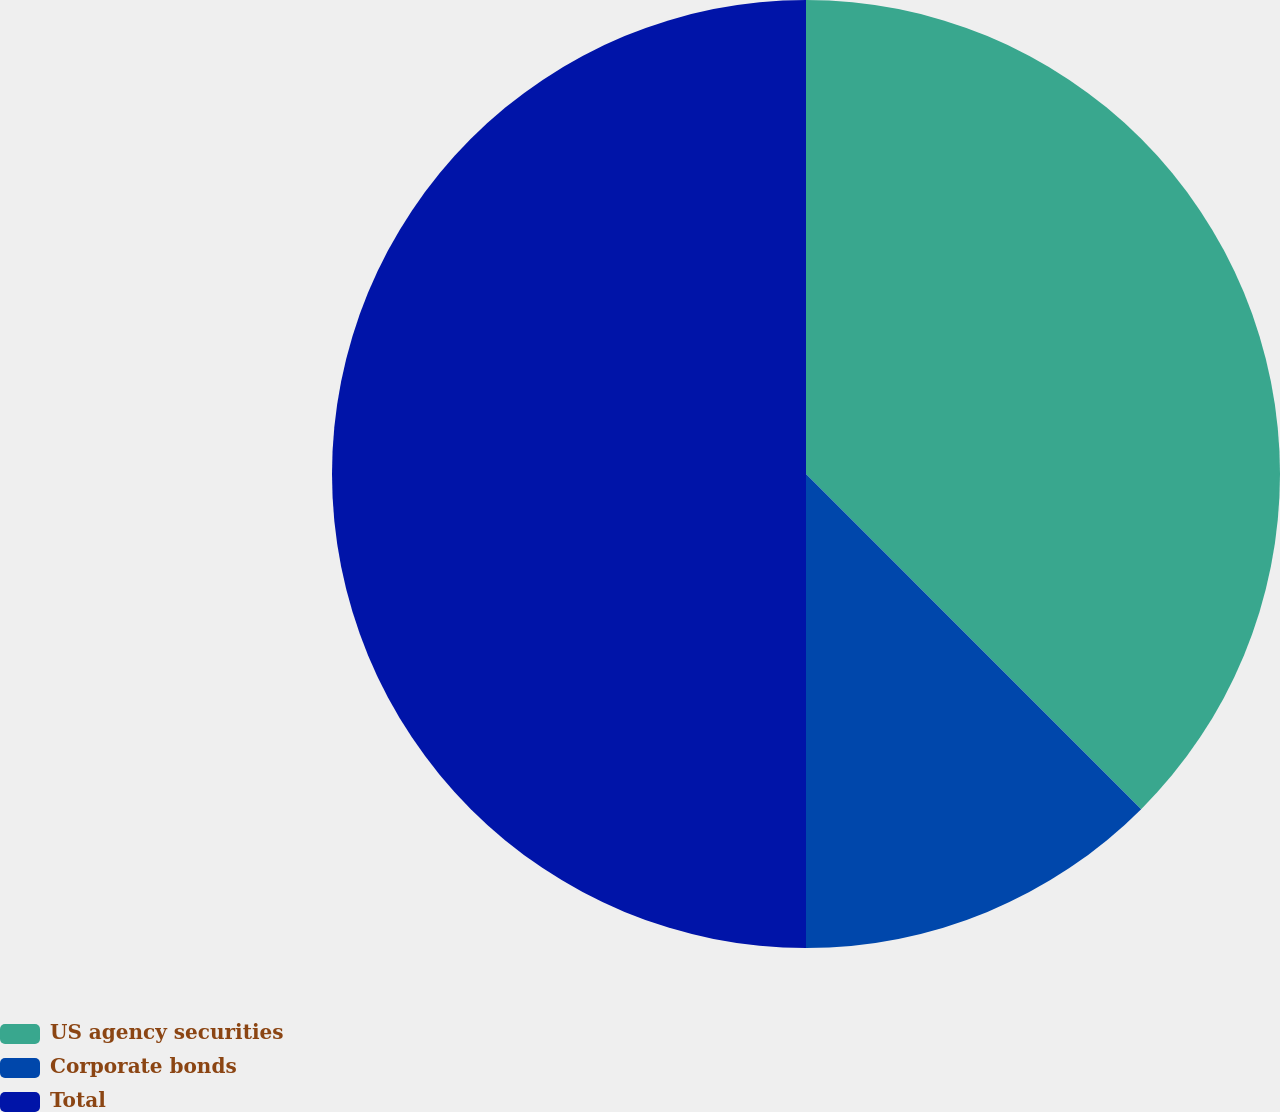Convert chart. <chart><loc_0><loc_0><loc_500><loc_500><pie_chart><fcel>US agency securities<fcel>Corporate bonds<fcel>Total<nl><fcel>37.5%<fcel>12.5%<fcel>50.0%<nl></chart> 